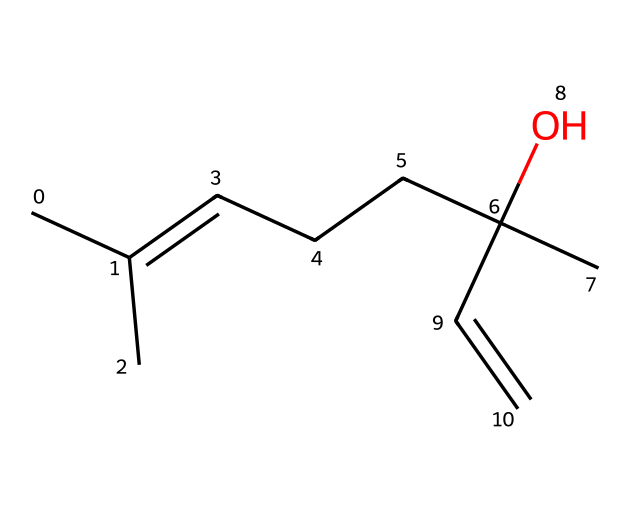What is the molecular formula of Linalool? To determine the molecular formula, count the number of carbon (C), hydrogen (H), and oxygen (O) atoms in the SMILES. The structure indicates there are 10 carbons, 18 hydrogens, and 1 oxygen. Thus, the molecular formula is C10H18O.
Answer: C10H18O How many double bonds are present in Linalool? Examine the structural representation; double bonds are indicated by the "=" symbol. In the provided SMILES, there are two occurrences of "=" indicating there are two double bonds in the molecule.
Answer: 2 What type of functional group is present due to the "O" in Linalool? The presence of "O" in the SMILES indicates an alcohol functional group, since it is associated with a carbon atom and appears in the context of a hydroxyl (-OH) group.
Answer: alcohol Which ring structure type is present in Linalool? Analyze the SMILES and identify that there are no numbers signifying ring closures (e.g., no "1", "2" etc.). Therefore, Linalool does not contain any ring structures; it is a linear acyclic compound.
Answer: none How many stereogenic centers does Linalool possess? To find the stereogenic centers, identify the carbon atoms bonded to four different substituents or groups. In this compound, there are two such centers where stereogenicity can occur, indicated by the presence of chiral centers.
Answer: 2 Is Linalool a cyclic or acyclic terpene? Based on the absence of any ring structures noted earlier in the SMILES, it's clear that Linalool maintains a straight-chain form as opposed to being cyclic. Therefore, we classify it as acyclic.
Answer: acyclic 